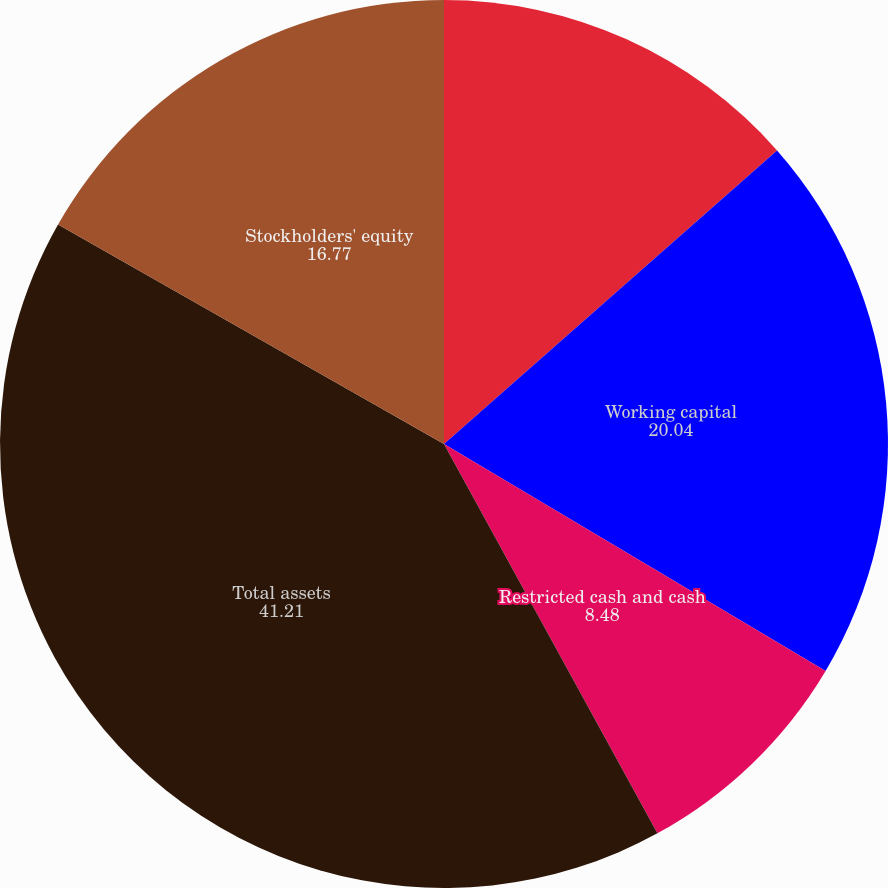<chart> <loc_0><loc_0><loc_500><loc_500><pie_chart><fcel>Cash and cash equivalents and<fcel>Working capital<fcel>Restricted cash and cash<fcel>Total assets<fcel>Stockholders' equity<nl><fcel>13.5%<fcel>20.04%<fcel>8.48%<fcel>41.21%<fcel>16.77%<nl></chart> 